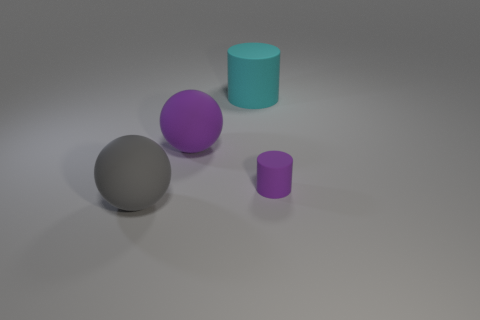Add 1 cyan rubber cylinders. How many objects exist? 5 Subtract 0 yellow cubes. How many objects are left? 4 Subtract all big gray rubber things. Subtract all large rubber balls. How many objects are left? 1 Add 3 tiny cylinders. How many tiny cylinders are left? 4 Add 1 small purple rubber balls. How many small purple rubber balls exist? 1 